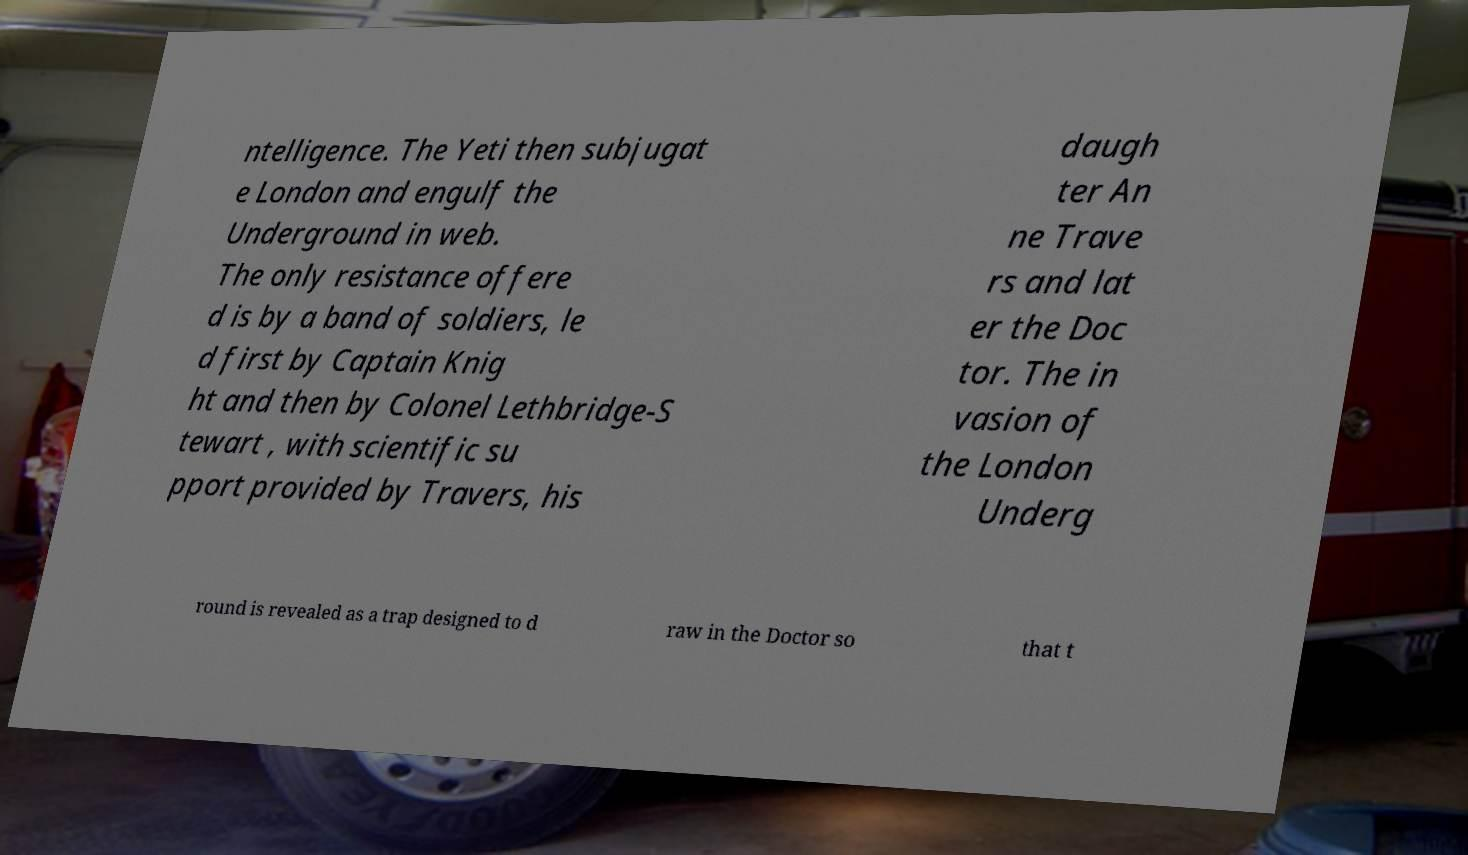There's text embedded in this image that I need extracted. Can you transcribe it verbatim? ntelligence. The Yeti then subjugat e London and engulf the Underground in web. The only resistance offere d is by a band of soldiers, le d first by Captain Knig ht and then by Colonel Lethbridge-S tewart , with scientific su pport provided by Travers, his daugh ter An ne Trave rs and lat er the Doc tor. The in vasion of the London Underg round is revealed as a trap designed to d raw in the Doctor so that t 